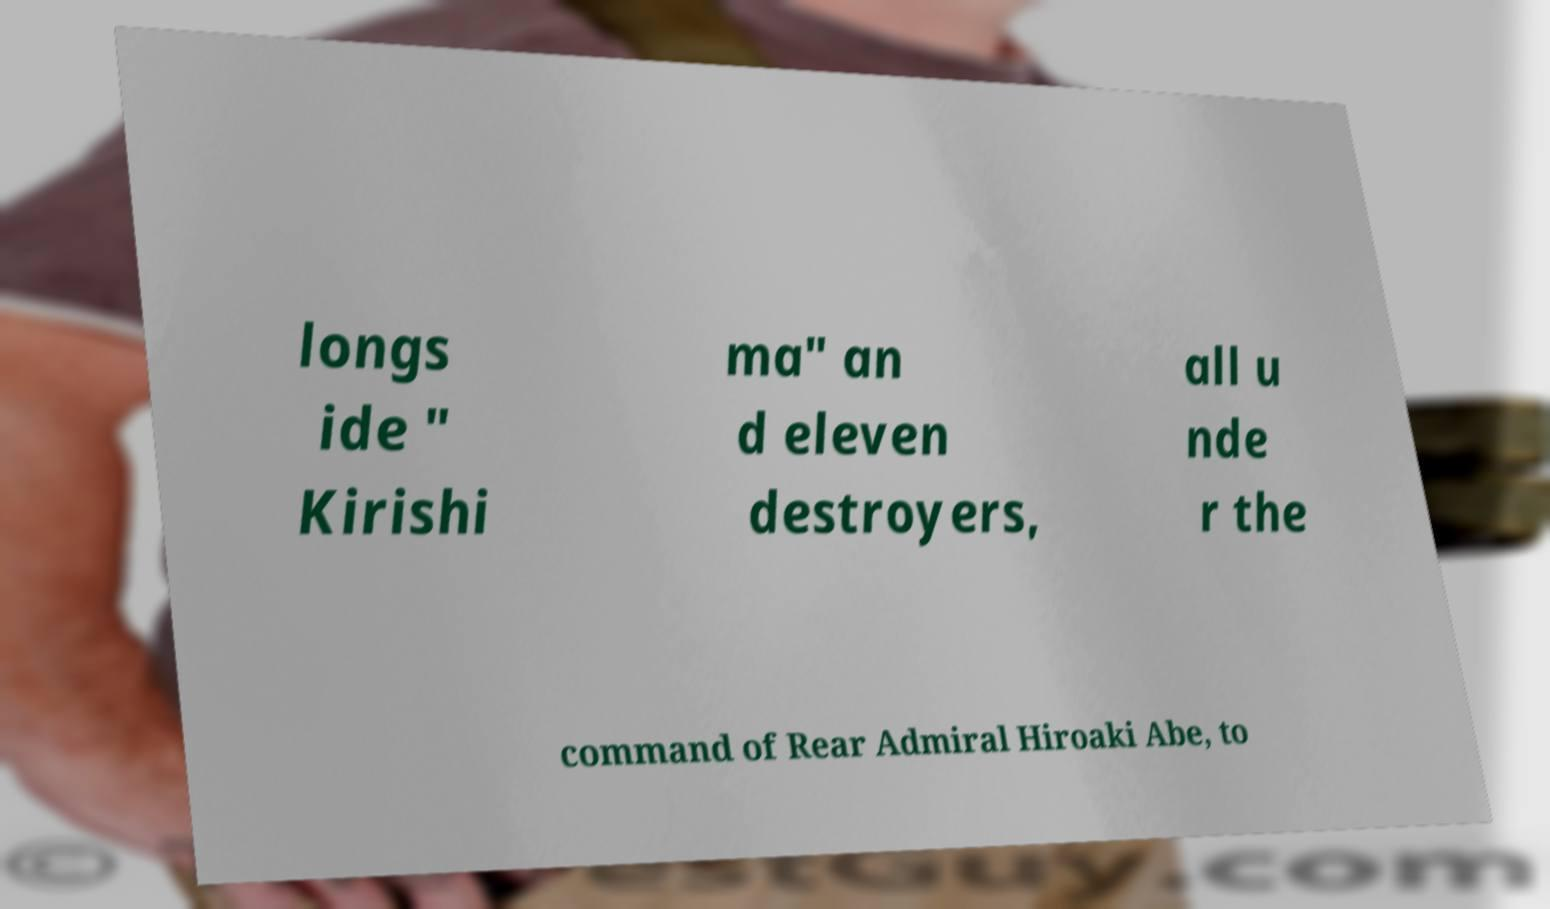There's text embedded in this image that I need extracted. Can you transcribe it verbatim? longs ide " Kirishi ma" an d eleven destroyers, all u nde r the command of Rear Admiral Hiroaki Abe, to 